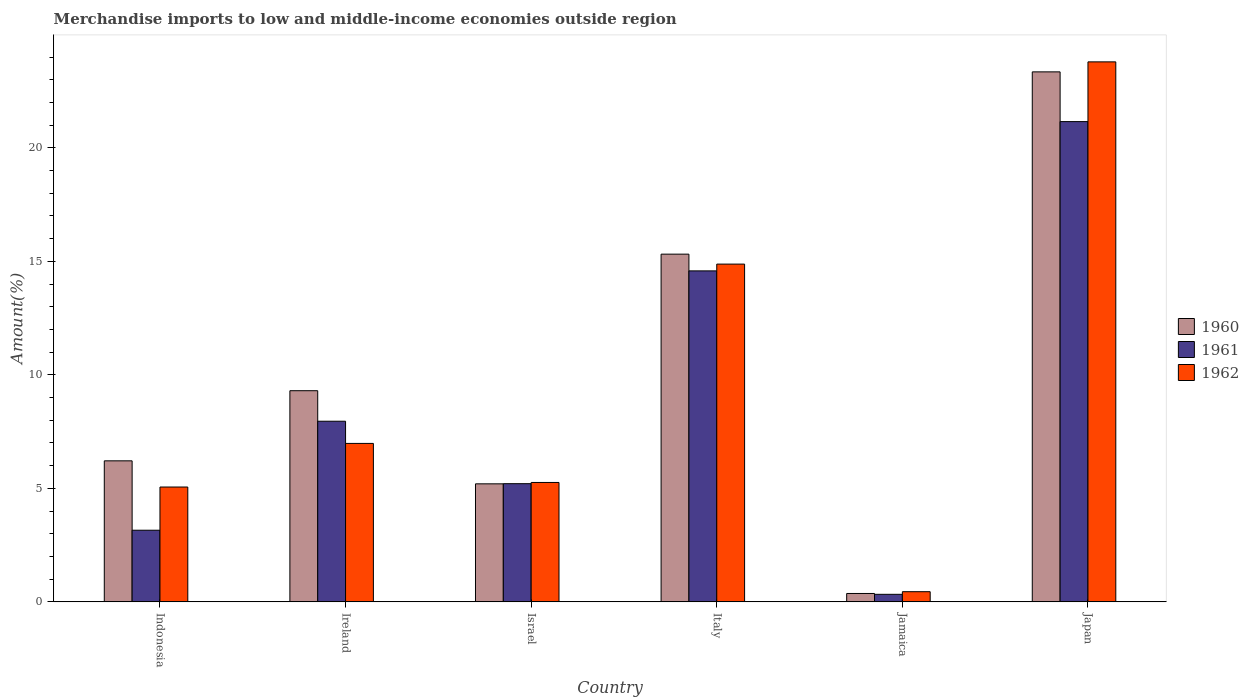How many groups of bars are there?
Your response must be concise. 6. Are the number of bars per tick equal to the number of legend labels?
Your answer should be compact. Yes. Are the number of bars on each tick of the X-axis equal?
Provide a short and direct response. Yes. How many bars are there on the 6th tick from the right?
Your response must be concise. 3. What is the label of the 4th group of bars from the left?
Offer a terse response. Italy. In how many cases, is the number of bars for a given country not equal to the number of legend labels?
Provide a short and direct response. 0. What is the percentage of amount earned from merchandise imports in 1960 in Israel?
Provide a short and direct response. 5.2. Across all countries, what is the maximum percentage of amount earned from merchandise imports in 1961?
Ensure brevity in your answer.  21.16. Across all countries, what is the minimum percentage of amount earned from merchandise imports in 1960?
Your response must be concise. 0.37. In which country was the percentage of amount earned from merchandise imports in 1961 maximum?
Ensure brevity in your answer.  Japan. In which country was the percentage of amount earned from merchandise imports in 1962 minimum?
Make the answer very short. Jamaica. What is the total percentage of amount earned from merchandise imports in 1962 in the graph?
Your answer should be very brief. 56.42. What is the difference between the percentage of amount earned from merchandise imports in 1961 in Indonesia and that in Jamaica?
Your response must be concise. 2.82. What is the difference between the percentage of amount earned from merchandise imports in 1961 in Indonesia and the percentage of amount earned from merchandise imports in 1962 in Israel?
Your response must be concise. -2.1. What is the average percentage of amount earned from merchandise imports in 1960 per country?
Your answer should be very brief. 9.96. What is the difference between the percentage of amount earned from merchandise imports of/in 1961 and percentage of amount earned from merchandise imports of/in 1960 in Israel?
Provide a short and direct response. 0.01. In how many countries, is the percentage of amount earned from merchandise imports in 1960 greater than 2 %?
Make the answer very short. 5. What is the ratio of the percentage of amount earned from merchandise imports in 1961 in Israel to that in Italy?
Your response must be concise. 0.36. What is the difference between the highest and the second highest percentage of amount earned from merchandise imports in 1961?
Keep it short and to the point. 6.58. What is the difference between the highest and the lowest percentage of amount earned from merchandise imports in 1961?
Keep it short and to the point. 20.83. What does the 3rd bar from the left in Indonesia represents?
Ensure brevity in your answer.  1962. What does the 3rd bar from the right in Indonesia represents?
Keep it short and to the point. 1960. Is it the case that in every country, the sum of the percentage of amount earned from merchandise imports in 1961 and percentage of amount earned from merchandise imports in 1962 is greater than the percentage of amount earned from merchandise imports in 1960?
Ensure brevity in your answer.  Yes. How many countries are there in the graph?
Give a very brief answer. 6. What is the difference between two consecutive major ticks on the Y-axis?
Provide a succinct answer. 5. Where does the legend appear in the graph?
Provide a succinct answer. Center right. What is the title of the graph?
Provide a short and direct response. Merchandise imports to low and middle-income economies outside region. What is the label or title of the X-axis?
Offer a very short reply. Country. What is the label or title of the Y-axis?
Give a very brief answer. Amount(%). What is the Amount(%) in 1960 in Indonesia?
Your answer should be very brief. 6.21. What is the Amount(%) of 1961 in Indonesia?
Offer a very short reply. 3.16. What is the Amount(%) in 1962 in Indonesia?
Provide a succinct answer. 5.06. What is the Amount(%) of 1960 in Ireland?
Make the answer very short. 9.3. What is the Amount(%) of 1961 in Ireland?
Make the answer very short. 7.96. What is the Amount(%) in 1962 in Ireland?
Provide a short and direct response. 6.98. What is the Amount(%) in 1960 in Israel?
Ensure brevity in your answer.  5.2. What is the Amount(%) in 1961 in Israel?
Your answer should be very brief. 5.21. What is the Amount(%) in 1962 in Israel?
Keep it short and to the point. 5.26. What is the Amount(%) of 1960 in Italy?
Offer a very short reply. 15.32. What is the Amount(%) of 1961 in Italy?
Provide a short and direct response. 14.58. What is the Amount(%) in 1962 in Italy?
Provide a succinct answer. 14.88. What is the Amount(%) of 1960 in Jamaica?
Provide a succinct answer. 0.37. What is the Amount(%) of 1961 in Jamaica?
Your answer should be compact. 0.33. What is the Amount(%) in 1962 in Jamaica?
Your answer should be compact. 0.45. What is the Amount(%) in 1960 in Japan?
Offer a terse response. 23.35. What is the Amount(%) in 1961 in Japan?
Your answer should be compact. 21.16. What is the Amount(%) in 1962 in Japan?
Your response must be concise. 23.79. Across all countries, what is the maximum Amount(%) of 1960?
Offer a terse response. 23.35. Across all countries, what is the maximum Amount(%) in 1961?
Your answer should be very brief. 21.16. Across all countries, what is the maximum Amount(%) of 1962?
Your answer should be very brief. 23.79. Across all countries, what is the minimum Amount(%) in 1960?
Offer a very short reply. 0.37. Across all countries, what is the minimum Amount(%) in 1961?
Offer a terse response. 0.33. Across all countries, what is the minimum Amount(%) of 1962?
Offer a terse response. 0.45. What is the total Amount(%) in 1960 in the graph?
Make the answer very short. 59.76. What is the total Amount(%) of 1961 in the graph?
Provide a short and direct response. 52.4. What is the total Amount(%) of 1962 in the graph?
Keep it short and to the point. 56.42. What is the difference between the Amount(%) in 1960 in Indonesia and that in Ireland?
Make the answer very short. -3.09. What is the difference between the Amount(%) of 1961 in Indonesia and that in Ireland?
Offer a terse response. -4.8. What is the difference between the Amount(%) in 1962 in Indonesia and that in Ireland?
Provide a short and direct response. -1.92. What is the difference between the Amount(%) of 1960 in Indonesia and that in Israel?
Your answer should be very brief. 1.01. What is the difference between the Amount(%) in 1961 in Indonesia and that in Israel?
Your answer should be very brief. -2.05. What is the difference between the Amount(%) of 1962 in Indonesia and that in Israel?
Keep it short and to the point. -0.2. What is the difference between the Amount(%) in 1960 in Indonesia and that in Italy?
Offer a terse response. -9.11. What is the difference between the Amount(%) in 1961 in Indonesia and that in Italy?
Ensure brevity in your answer.  -11.43. What is the difference between the Amount(%) in 1962 in Indonesia and that in Italy?
Provide a succinct answer. -9.82. What is the difference between the Amount(%) in 1960 in Indonesia and that in Jamaica?
Provide a succinct answer. 5.84. What is the difference between the Amount(%) in 1961 in Indonesia and that in Jamaica?
Keep it short and to the point. 2.82. What is the difference between the Amount(%) of 1962 in Indonesia and that in Jamaica?
Offer a terse response. 4.61. What is the difference between the Amount(%) of 1960 in Indonesia and that in Japan?
Your answer should be very brief. -17.14. What is the difference between the Amount(%) in 1961 in Indonesia and that in Japan?
Ensure brevity in your answer.  -18. What is the difference between the Amount(%) of 1962 in Indonesia and that in Japan?
Your answer should be very brief. -18.73. What is the difference between the Amount(%) of 1960 in Ireland and that in Israel?
Provide a succinct answer. 4.1. What is the difference between the Amount(%) of 1961 in Ireland and that in Israel?
Your answer should be very brief. 2.75. What is the difference between the Amount(%) in 1962 in Ireland and that in Israel?
Ensure brevity in your answer.  1.72. What is the difference between the Amount(%) in 1960 in Ireland and that in Italy?
Your answer should be very brief. -6.02. What is the difference between the Amount(%) in 1961 in Ireland and that in Italy?
Keep it short and to the point. -6.62. What is the difference between the Amount(%) in 1962 in Ireland and that in Italy?
Your answer should be compact. -7.9. What is the difference between the Amount(%) of 1960 in Ireland and that in Jamaica?
Provide a short and direct response. 8.93. What is the difference between the Amount(%) of 1961 in Ireland and that in Jamaica?
Ensure brevity in your answer.  7.63. What is the difference between the Amount(%) of 1962 in Ireland and that in Jamaica?
Provide a short and direct response. 6.53. What is the difference between the Amount(%) of 1960 in Ireland and that in Japan?
Ensure brevity in your answer.  -14.05. What is the difference between the Amount(%) of 1961 in Ireland and that in Japan?
Your answer should be compact. -13.2. What is the difference between the Amount(%) of 1962 in Ireland and that in Japan?
Make the answer very short. -16.81. What is the difference between the Amount(%) in 1960 in Israel and that in Italy?
Your answer should be very brief. -10.12. What is the difference between the Amount(%) of 1961 in Israel and that in Italy?
Provide a succinct answer. -9.38. What is the difference between the Amount(%) in 1962 in Israel and that in Italy?
Give a very brief answer. -9.62. What is the difference between the Amount(%) of 1960 in Israel and that in Jamaica?
Offer a very short reply. 4.83. What is the difference between the Amount(%) of 1961 in Israel and that in Jamaica?
Ensure brevity in your answer.  4.87. What is the difference between the Amount(%) in 1962 in Israel and that in Jamaica?
Give a very brief answer. 4.81. What is the difference between the Amount(%) of 1960 in Israel and that in Japan?
Make the answer very short. -18.15. What is the difference between the Amount(%) in 1961 in Israel and that in Japan?
Offer a very short reply. -15.95. What is the difference between the Amount(%) of 1962 in Israel and that in Japan?
Your answer should be very brief. -18.53. What is the difference between the Amount(%) of 1960 in Italy and that in Jamaica?
Your response must be concise. 14.95. What is the difference between the Amount(%) in 1961 in Italy and that in Jamaica?
Provide a succinct answer. 14.25. What is the difference between the Amount(%) of 1962 in Italy and that in Jamaica?
Ensure brevity in your answer.  14.43. What is the difference between the Amount(%) of 1960 in Italy and that in Japan?
Offer a very short reply. -8.03. What is the difference between the Amount(%) of 1961 in Italy and that in Japan?
Ensure brevity in your answer.  -6.58. What is the difference between the Amount(%) in 1962 in Italy and that in Japan?
Provide a short and direct response. -8.91. What is the difference between the Amount(%) of 1960 in Jamaica and that in Japan?
Keep it short and to the point. -22.98. What is the difference between the Amount(%) in 1961 in Jamaica and that in Japan?
Offer a very short reply. -20.83. What is the difference between the Amount(%) of 1962 in Jamaica and that in Japan?
Provide a succinct answer. -23.34. What is the difference between the Amount(%) in 1960 in Indonesia and the Amount(%) in 1961 in Ireland?
Give a very brief answer. -1.74. What is the difference between the Amount(%) in 1960 in Indonesia and the Amount(%) in 1962 in Ireland?
Your response must be concise. -0.77. What is the difference between the Amount(%) of 1961 in Indonesia and the Amount(%) of 1962 in Ireland?
Your answer should be very brief. -3.82. What is the difference between the Amount(%) of 1960 in Indonesia and the Amount(%) of 1962 in Israel?
Your response must be concise. 0.95. What is the difference between the Amount(%) of 1961 in Indonesia and the Amount(%) of 1962 in Israel?
Your answer should be very brief. -2.1. What is the difference between the Amount(%) of 1960 in Indonesia and the Amount(%) of 1961 in Italy?
Provide a succinct answer. -8.37. What is the difference between the Amount(%) of 1960 in Indonesia and the Amount(%) of 1962 in Italy?
Offer a terse response. -8.67. What is the difference between the Amount(%) in 1961 in Indonesia and the Amount(%) in 1962 in Italy?
Offer a terse response. -11.72. What is the difference between the Amount(%) in 1960 in Indonesia and the Amount(%) in 1961 in Jamaica?
Make the answer very short. 5.88. What is the difference between the Amount(%) in 1960 in Indonesia and the Amount(%) in 1962 in Jamaica?
Provide a short and direct response. 5.76. What is the difference between the Amount(%) of 1961 in Indonesia and the Amount(%) of 1962 in Jamaica?
Your answer should be compact. 2.71. What is the difference between the Amount(%) of 1960 in Indonesia and the Amount(%) of 1961 in Japan?
Your answer should be very brief. -14.95. What is the difference between the Amount(%) of 1960 in Indonesia and the Amount(%) of 1962 in Japan?
Give a very brief answer. -17.58. What is the difference between the Amount(%) of 1961 in Indonesia and the Amount(%) of 1962 in Japan?
Offer a terse response. -20.63. What is the difference between the Amount(%) of 1960 in Ireland and the Amount(%) of 1961 in Israel?
Give a very brief answer. 4.1. What is the difference between the Amount(%) of 1960 in Ireland and the Amount(%) of 1962 in Israel?
Your response must be concise. 4.04. What is the difference between the Amount(%) in 1961 in Ireland and the Amount(%) in 1962 in Israel?
Make the answer very short. 2.7. What is the difference between the Amount(%) of 1960 in Ireland and the Amount(%) of 1961 in Italy?
Offer a terse response. -5.28. What is the difference between the Amount(%) in 1960 in Ireland and the Amount(%) in 1962 in Italy?
Your answer should be very brief. -5.58. What is the difference between the Amount(%) in 1961 in Ireland and the Amount(%) in 1962 in Italy?
Give a very brief answer. -6.92. What is the difference between the Amount(%) in 1960 in Ireland and the Amount(%) in 1961 in Jamaica?
Offer a very short reply. 8.97. What is the difference between the Amount(%) in 1960 in Ireland and the Amount(%) in 1962 in Jamaica?
Ensure brevity in your answer.  8.85. What is the difference between the Amount(%) in 1961 in Ireland and the Amount(%) in 1962 in Jamaica?
Provide a short and direct response. 7.51. What is the difference between the Amount(%) of 1960 in Ireland and the Amount(%) of 1961 in Japan?
Offer a terse response. -11.86. What is the difference between the Amount(%) of 1960 in Ireland and the Amount(%) of 1962 in Japan?
Ensure brevity in your answer.  -14.49. What is the difference between the Amount(%) of 1961 in Ireland and the Amount(%) of 1962 in Japan?
Ensure brevity in your answer.  -15.83. What is the difference between the Amount(%) in 1960 in Israel and the Amount(%) in 1961 in Italy?
Offer a very short reply. -9.38. What is the difference between the Amount(%) in 1960 in Israel and the Amount(%) in 1962 in Italy?
Offer a terse response. -9.68. What is the difference between the Amount(%) of 1961 in Israel and the Amount(%) of 1962 in Italy?
Offer a very short reply. -9.67. What is the difference between the Amount(%) in 1960 in Israel and the Amount(%) in 1961 in Jamaica?
Keep it short and to the point. 4.87. What is the difference between the Amount(%) in 1960 in Israel and the Amount(%) in 1962 in Jamaica?
Your answer should be very brief. 4.75. What is the difference between the Amount(%) of 1961 in Israel and the Amount(%) of 1962 in Jamaica?
Provide a short and direct response. 4.76. What is the difference between the Amount(%) of 1960 in Israel and the Amount(%) of 1961 in Japan?
Your response must be concise. -15.96. What is the difference between the Amount(%) of 1960 in Israel and the Amount(%) of 1962 in Japan?
Ensure brevity in your answer.  -18.59. What is the difference between the Amount(%) in 1961 in Israel and the Amount(%) in 1962 in Japan?
Your response must be concise. -18.58. What is the difference between the Amount(%) of 1960 in Italy and the Amount(%) of 1961 in Jamaica?
Make the answer very short. 14.99. What is the difference between the Amount(%) of 1960 in Italy and the Amount(%) of 1962 in Jamaica?
Provide a short and direct response. 14.87. What is the difference between the Amount(%) of 1961 in Italy and the Amount(%) of 1962 in Jamaica?
Give a very brief answer. 14.13. What is the difference between the Amount(%) of 1960 in Italy and the Amount(%) of 1961 in Japan?
Give a very brief answer. -5.84. What is the difference between the Amount(%) of 1960 in Italy and the Amount(%) of 1962 in Japan?
Give a very brief answer. -8.47. What is the difference between the Amount(%) of 1961 in Italy and the Amount(%) of 1962 in Japan?
Make the answer very short. -9.21. What is the difference between the Amount(%) in 1960 in Jamaica and the Amount(%) in 1961 in Japan?
Give a very brief answer. -20.79. What is the difference between the Amount(%) in 1960 in Jamaica and the Amount(%) in 1962 in Japan?
Your response must be concise. -23.42. What is the difference between the Amount(%) in 1961 in Jamaica and the Amount(%) in 1962 in Japan?
Make the answer very short. -23.46. What is the average Amount(%) in 1960 per country?
Offer a very short reply. 9.96. What is the average Amount(%) in 1961 per country?
Your response must be concise. 8.73. What is the average Amount(%) of 1962 per country?
Your answer should be very brief. 9.4. What is the difference between the Amount(%) in 1960 and Amount(%) in 1961 in Indonesia?
Make the answer very short. 3.06. What is the difference between the Amount(%) in 1960 and Amount(%) in 1962 in Indonesia?
Your answer should be very brief. 1.15. What is the difference between the Amount(%) of 1961 and Amount(%) of 1962 in Indonesia?
Give a very brief answer. -1.9. What is the difference between the Amount(%) in 1960 and Amount(%) in 1961 in Ireland?
Provide a short and direct response. 1.34. What is the difference between the Amount(%) in 1960 and Amount(%) in 1962 in Ireland?
Make the answer very short. 2.32. What is the difference between the Amount(%) in 1961 and Amount(%) in 1962 in Ireland?
Provide a short and direct response. 0.98. What is the difference between the Amount(%) in 1960 and Amount(%) in 1961 in Israel?
Provide a succinct answer. -0.01. What is the difference between the Amount(%) of 1960 and Amount(%) of 1962 in Israel?
Your answer should be very brief. -0.06. What is the difference between the Amount(%) in 1961 and Amount(%) in 1962 in Israel?
Your answer should be compact. -0.05. What is the difference between the Amount(%) in 1960 and Amount(%) in 1961 in Italy?
Offer a very short reply. 0.74. What is the difference between the Amount(%) in 1960 and Amount(%) in 1962 in Italy?
Offer a terse response. 0.44. What is the difference between the Amount(%) of 1961 and Amount(%) of 1962 in Italy?
Ensure brevity in your answer.  -0.3. What is the difference between the Amount(%) of 1960 and Amount(%) of 1961 in Jamaica?
Offer a very short reply. 0.04. What is the difference between the Amount(%) in 1960 and Amount(%) in 1962 in Jamaica?
Keep it short and to the point. -0.08. What is the difference between the Amount(%) of 1961 and Amount(%) of 1962 in Jamaica?
Your response must be concise. -0.12. What is the difference between the Amount(%) of 1960 and Amount(%) of 1961 in Japan?
Provide a short and direct response. 2.19. What is the difference between the Amount(%) in 1960 and Amount(%) in 1962 in Japan?
Keep it short and to the point. -0.44. What is the difference between the Amount(%) of 1961 and Amount(%) of 1962 in Japan?
Offer a terse response. -2.63. What is the ratio of the Amount(%) in 1960 in Indonesia to that in Ireland?
Make the answer very short. 0.67. What is the ratio of the Amount(%) in 1961 in Indonesia to that in Ireland?
Give a very brief answer. 0.4. What is the ratio of the Amount(%) of 1962 in Indonesia to that in Ireland?
Make the answer very short. 0.72. What is the ratio of the Amount(%) in 1960 in Indonesia to that in Israel?
Make the answer very short. 1.19. What is the ratio of the Amount(%) in 1961 in Indonesia to that in Israel?
Provide a succinct answer. 0.61. What is the ratio of the Amount(%) of 1962 in Indonesia to that in Israel?
Provide a succinct answer. 0.96. What is the ratio of the Amount(%) in 1960 in Indonesia to that in Italy?
Ensure brevity in your answer.  0.41. What is the ratio of the Amount(%) of 1961 in Indonesia to that in Italy?
Keep it short and to the point. 0.22. What is the ratio of the Amount(%) in 1962 in Indonesia to that in Italy?
Provide a succinct answer. 0.34. What is the ratio of the Amount(%) in 1960 in Indonesia to that in Jamaica?
Your answer should be compact. 16.78. What is the ratio of the Amount(%) of 1961 in Indonesia to that in Jamaica?
Offer a very short reply. 9.49. What is the ratio of the Amount(%) of 1962 in Indonesia to that in Jamaica?
Offer a very short reply. 11.28. What is the ratio of the Amount(%) in 1960 in Indonesia to that in Japan?
Keep it short and to the point. 0.27. What is the ratio of the Amount(%) of 1961 in Indonesia to that in Japan?
Your answer should be compact. 0.15. What is the ratio of the Amount(%) of 1962 in Indonesia to that in Japan?
Give a very brief answer. 0.21. What is the ratio of the Amount(%) of 1960 in Ireland to that in Israel?
Provide a short and direct response. 1.79. What is the ratio of the Amount(%) of 1961 in Ireland to that in Israel?
Keep it short and to the point. 1.53. What is the ratio of the Amount(%) of 1962 in Ireland to that in Israel?
Provide a short and direct response. 1.33. What is the ratio of the Amount(%) in 1960 in Ireland to that in Italy?
Ensure brevity in your answer.  0.61. What is the ratio of the Amount(%) in 1961 in Ireland to that in Italy?
Ensure brevity in your answer.  0.55. What is the ratio of the Amount(%) in 1962 in Ireland to that in Italy?
Ensure brevity in your answer.  0.47. What is the ratio of the Amount(%) of 1960 in Ireland to that in Jamaica?
Offer a very short reply. 25.13. What is the ratio of the Amount(%) in 1961 in Ireland to that in Jamaica?
Your answer should be compact. 23.92. What is the ratio of the Amount(%) in 1962 in Ireland to that in Jamaica?
Make the answer very short. 15.56. What is the ratio of the Amount(%) of 1960 in Ireland to that in Japan?
Offer a very short reply. 0.4. What is the ratio of the Amount(%) of 1961 in Ireland to that in Japan?
Make the answer very short. 0.38. What is the ratio of the Amount(%) in 1962 in Ireland to that in Japan?
Make the answer very short. 0.29. What is the ratio of the Amount(%) of 1960 in Israel to that in Italy?
Provide a short and direct response. 0.34. What is the ratio of the Amount(%) of 1961 in Israel to that in Italy?
Your answer should be very brief. 0.36. What is the ratio of the Amount(%) of 1962 in Israel to that in Italy?
Ensure brevity in your answer.  0.35. What is the ratio of the Amount(%) in 1960 in Israel to that in Jamaica?
Make the answer very short. 14.05. What is the ratio of the Amount(%) in 1961 in Israel to that in Jamaica?
Give a very brief answer. 15.65. What is the ratio of the Amount(%) of 1962 in Israel to that in Jamaica?
Offer a very short reply. 11.73. What is the ratio of the Amount(%) in 1960 in Israel to that in Japan?
Offer a terse response. 0.22. What is the ratio of the Amount(%) of 1961 in Israel to that in Japan?
Your response must be concise. 0.25. What is the ratio of the Amount(%) of 1962 in Israel to that in Japan?
Offer a terse response. 0.22. What is the ratio of the Amount(%) in 1960 in Italy to that in Jamaica?
Offer a very short reply. 41.38. What is the ratio of the Amount(%) in 1961 in Italy to that in Jamaica?
Your answer should be very brief. 43.83. What is the ratio of the Amount(%) in 1962 in Italy to that in Jamaica?
Offer a terse response. 33.17. What is the ratio of the Amount(%) in 1960 in Italy to that in Japan?
Offer a very short reply. 0.66. What is the ratio of the Amount(%) of 1961 in Italy to that in Japan?
Your response must be concise. 0.69. What is the ratio of the Amount(%) in 1962 in Italy to that in Japan?
Your response must be concise. 0.63. What is the ratio of the Amount(%) in 1960 in Jamaica to that in Japan?
Offer a very short reply. 0.02. What is the ratio of the Amount(%) in 1961 in Jamaica to that in Japan?
Keep it short and to the point. 0.02. What is the ratio of the Amount(%) of 1962 in Jamaica to that in Japan?
Your answer should be very brief. 0.02. What is the difference between the highest and the second highest Amount(%) in 1960?
Offer a terse response. 8.03. What is the difference between the highest and the second highest Amount(%) in 1961?
Offer a very short reply. 6.58. What is the difference between the highest and the second highest Amount(%) in 1962?
Ensure brevity in your answer.  8.91. What is the difference between the highest and the lowest Amount(%) of 1960?
Offer a terse response. 22.98. What is the difference between the highest and the lowest Amount(%) of 1961?
Provide a short and direct response. 20.83. What is the difference between the highest and the lowest Amount(%) in 1962?
Give a very brief answer. 23.34. 